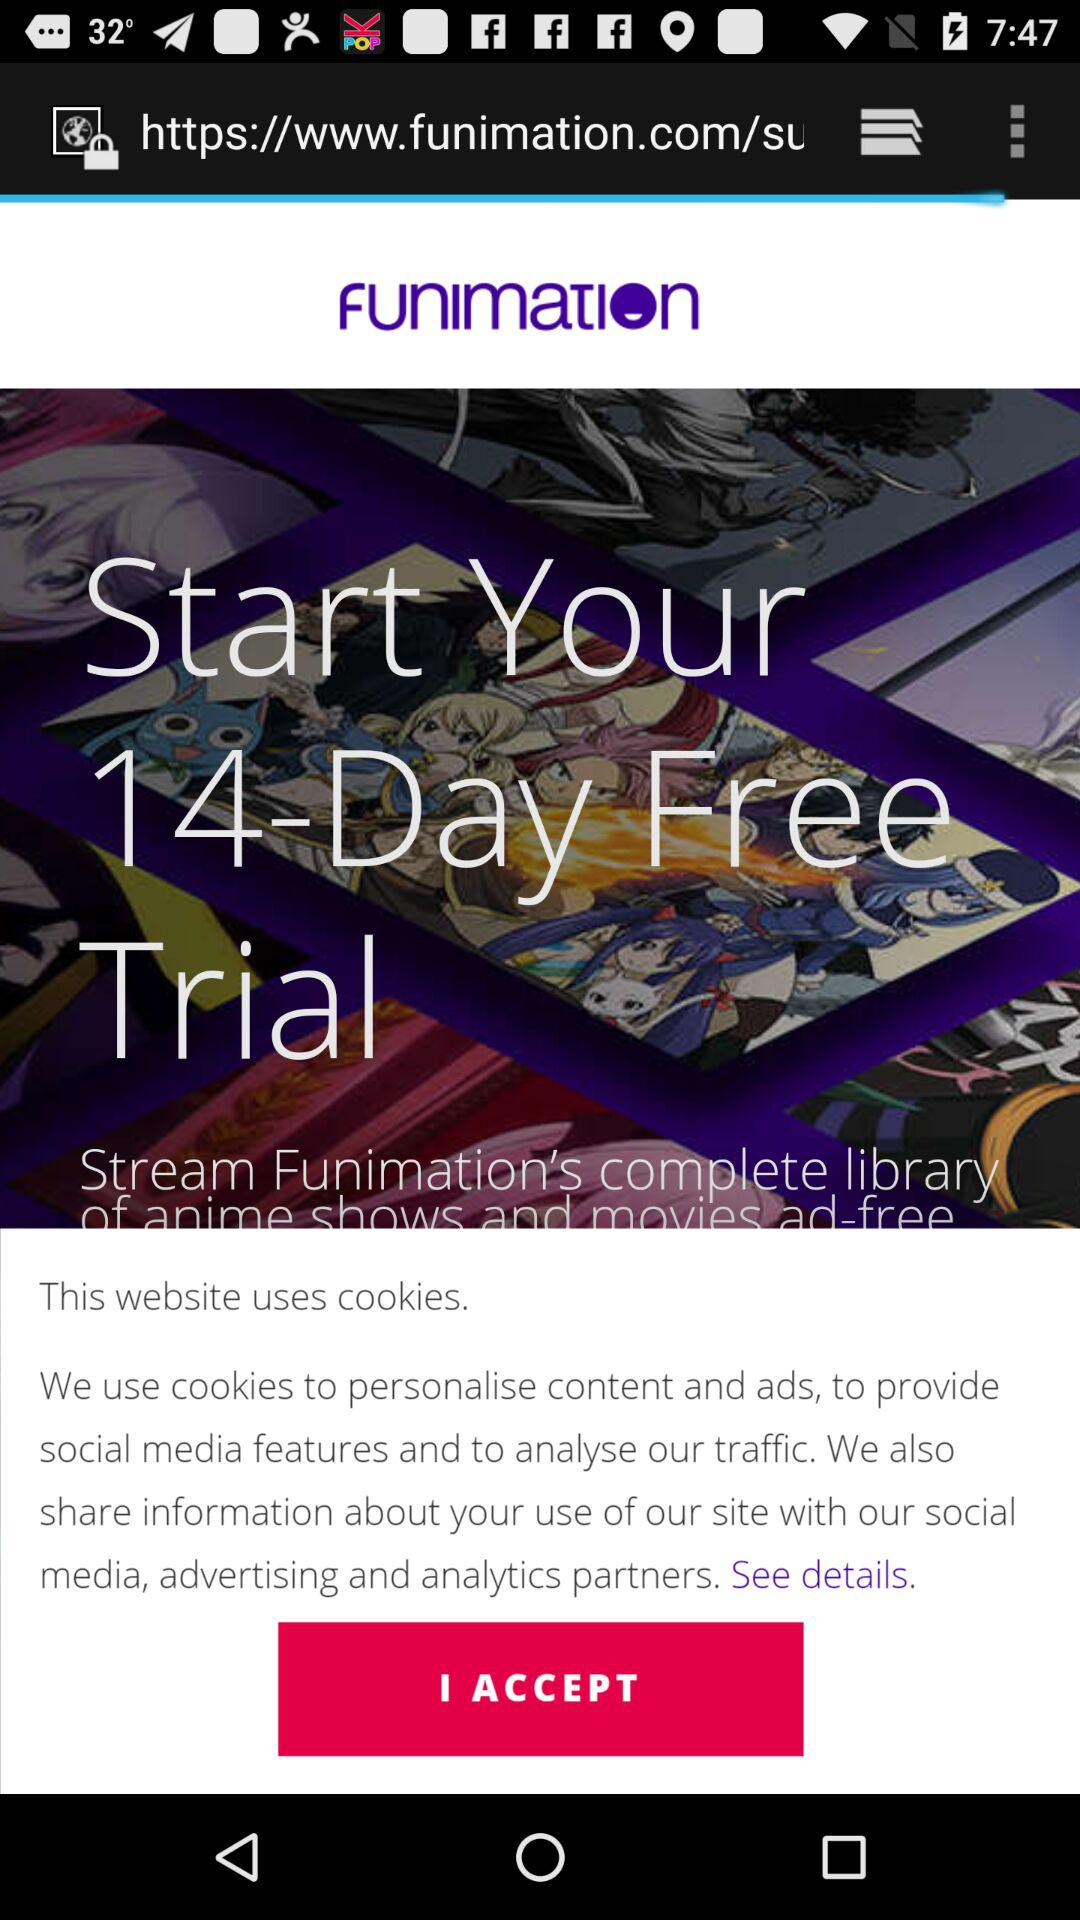For how many days is the free trial? The free trial is for 14 days. 